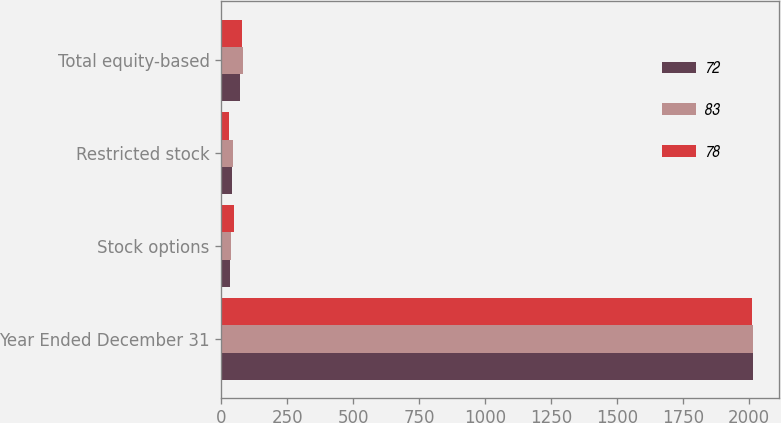Convert chart to OTSL. <chart><loc_0><loc_0><loc_500><loc_500><stacked_bar_chart><ecel><fcel>Year Ended December 31<fcel>Stock options<fcel>Restricted stock<fcel>Total equity-based<nl><fcel>72<fcel>2015<fcel>32<fcel>40<fcel>72<nl><fcel>83<fcel>2014<fcel>38<fcel>45<fcel>83<nl><fcel>78<fcel>2013<fcel>48<fcel>30<fcel>78<nl></chart> 